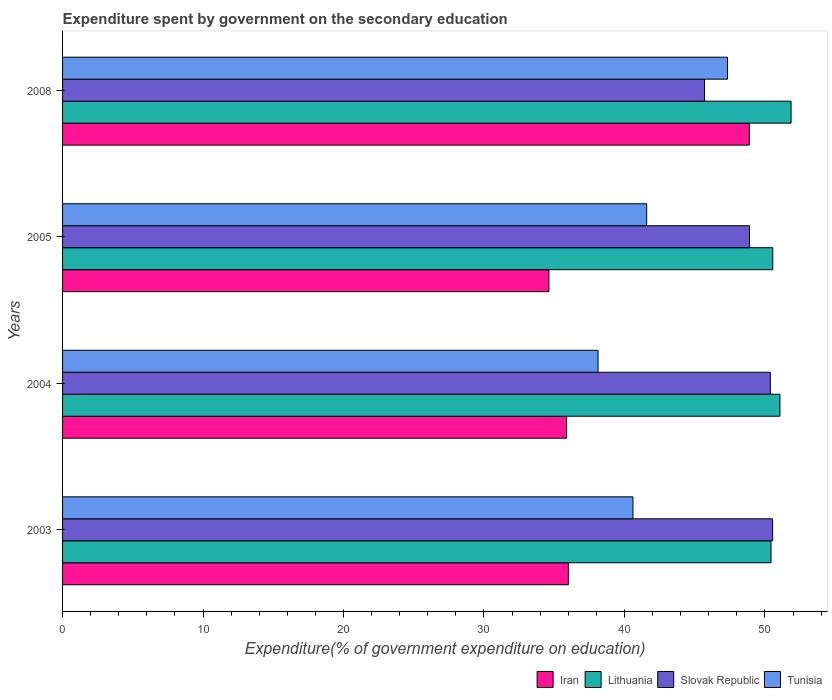How many different coloured bars are there?
Make the answer very short. 4. How many groups of bars are there?
Ensure brevity in your answer.  4. Are the number of bars per tick equal to the number of legend labels?
Ensure brevity in your answer.  Yes. Are the number of bars on each tick of the Y-axis equal?
Provide a short and direct response. Yes. How many bars are there on the 3rd tick from the top?
Offer a very short reply. 4. In how many cases, is the number of bars for a given year not equal to the number of legend labels?
Give a very brief answer. 0. What is the expenditure spent by government on the secondary education in Tunisia in 2003?
Make the answer very short. 40.61. Across all years, what is the maximum expenditure spent by government on the secondary education in Iran?
Give a very brief answer. 48.89. Across all years, what is the minimum expenditure spent by government on the secondary education in Tunisia?
Ensure brevity in your answer.  38.12. What is the total expenditure spent by government on the secondary education in Slovak Republic in the graph?
Your response must be concise. 195.54. What is the difference between the expenditure spent by government on the secondary education in Lithuania in 2003 and that in 2005?
Ensure brevity in your answer.  -0.13. What is the difference between the expenditure spent by government on the secondary education in Iran in 2004 and the expenditure spent by government on the secondary education in Slovak Republic in 2008?
Keep it short and to the point. -9.82. What is the average expenditure spent by government on the secondary education in Tunisia per year?
Offer a very short reply. 41.91. In the year 2003, what is the difference between the expenditure spent by government on the secondary education in Lithuania and expenditure spent by government on the secondary education in Tunisia?
Offer a very short reply. 9.83. In how many years, is the expenditure spent by government on the secondary education in Lithuania greater than 28 %?
Offer a very short reply. 4. What is the ratio of the expenditure spent by government on the secondary education in Slovak Republic in 2003 to that in 2008?
Give a very brief answer. 1.11. What is the difference between the highest and the second highest expenditure spent by government on the secondary education in Tunisia?
Your answer should be very brief. 5.76. What is the difference between the highest and the lowest expenditure spent by government on the secondary education in Iran?
Keep it short and to the point. 14.26. In how many years, is the expenditure spent by government on the secondary education in Slovak Republic greater than the average expenditure spent by government on the secondary education in Slovak Republic taken over all years?
Provide a succinct answer. 3. What does the 1st bar from the top in 2004 represents?
Your response must be concise. Tunisia. What does the 1st bar from the bottom in 2003 represents?
Your response must be concise. Iran. Is it the case that in every year, the sum of the expenditure spent by government on the secondary education in Tunisia and expenditure spent by government on the secondary education in Lithuania is greater than the expenditure spent by government on the secondary education in Iran?
Give a very brief answer. Yes. How many bars are there?
Provide a succinct answer. 16. What is the difference between two consecutive major ticks on the X-axis?
Keep it short and to the point. 10. Are the values on the major ticks of X-axis written in scientific E-notation?
Ensure brevity in your answer.  No. Does the graph contain any zero values?
Your answer should be very brief. No. How many legend labels are there?
Provide a short and direct response. 4. What is the title of the graph?
Your answer should be very brief. Expenditure spent by government on the secondary education. Does "Cuba" appear as one of the legend labels in the graph?
Your answer should be very brief. No. What is the label or title of the X-axis?
Your response must be concise. Expenditure(% of government expenditure on education). What is the label or title of the Y-axis?
Ensure brevity in your answer.  Years. What is the Expenditure(% of government expenditure on education) of Iran in 2003?
Your answer should be compact. 36.01. What is the Expenditure(% of government expenditure on education) of Lithuania in 2003?
Your response must be concise. 50.43. What is the Expenditure(% of government expenditure on education) in Slovak Republic in 2003?
Ensure brevity in your answer.  50.55. What is the Expenditure(% of government expenditure on education) of Tunisia in 2003?
Keep it short and to the point. 40.61. What is the Expenditure(% of government expenditure on education) in Iran in 2004?
Provide a short and direct response. 35.88. What is the Expenditure(% of government expenditure on education) of Lithuania in 2004?
Offer a terse response. 51.07. What is the Expenditure(% of government expenditure on education) of Slovak Republic in 2004?
Provide a short and direct response. 50.39. What is the Expenditure(% of government expenditure on education) in Tunisia in 2004?
Ensure brevity in your answer.  38.12. What is the Expenditure(% of government expenditure on education) in Iran in 2005?
Your answer should be compact. 34.62. What is the Expenditure(% of government expenditure on education) in Lithuania in 2005?
Offer a terse response. 50.56. What is the Expenditure(% of government expenditure on education) in Slovak Republic in 2005?
Your answer should be compact. 48.9. What is the Expenditure(% of government expenditure on education) of Tunisia in 2005?
Provide a succinct answer. 41.58. What is the Expenditure(% of government expenditure on education) in Iran in 2008?
Keep it short and to the point. 48.89. What is the Expenditure(% of government expenditure on education) in Lithuania in 2008?
Provide a short and direct response. 51.86. What is the Expenditure(% of government expenditure on education) in Slovak Republic in 2008?
Your response must be concise. 45.7. What is the Expenditure(% of government expenditure on education) of Tunisia in 2008?
Offer a very short reply. 47.34. Across all years, what is the maximum Expenditure(% of government expenditure on education) in Iran?
Make the answer very short. 48.89. Across all years, what is the maximum Expenditure(% of government expenditure on education) in Lithuania?
Your answer should be very brief. 51.86. Across all years, what is the maximum Expenditure(% of government expenditure on education) in Slovak Republic?
Your response must be concise. 50.55. Across all years, what is the maximum Expenditure(% of government expenditure on education) in Tunisia?
Keep it short and to the point. 47.34. Across all years, what is the minimum Expenditure(% of government expenditure on education) of Iran?
Offer a terse response. 34.62. Across all years, what is the minimum Expenditure(% of government expenditure on education) in Lithuania?
Provide a short and direct response. 50.43. Across all years, what is the minimum Expenditure(% of government expenditure on education) of Slovak Republic?
Make the answer very short. 45.7. Across all years, what is the minimum Expenditure(% of government expenditure on education) in Tunisia?
Your answer should be compact. 38.12. What is the total Expenditure(% of government expenditure on education) of Iran in the graph?
Ensure brevity in your answer.  155.4. What is the total Expenditure(% of government expenditure on education) of Lithuania in the graph?
Give a very brief answer. 203.93. What is the total Expenditure(% of government expenditure on education) in Slovak Republic in the graph?
Make the answer very short. 195.54. What is the total Expenditure(% of government expenditure on education) in Tunisia in the graph?
Ensure brevity in your answer.  167.65. What is the difference between the Expenditure(% of government expenditure on education) in Iran in 2003 and that in 2004?
Your answer should be very brief. 0.13. What is the difference between the Expenditure(% of government expenditure on education) of Lithuania in 2003 and that in 2004?
Ensure brevity in your answer.  -0.64. What is the difference between the Expenditure(% of government expenditure on education) of Slovak Republic in 2003 and that in 2004?
Ensure brevity in your answer.  0.17. What is the difference between the Expenditure(% of government expenditure on education) in Tunisia in 2003 and that in 2004?
Provide a succinct answer. 2.49. What is the difference between the Expenditure(% of government expenditure on education) in Iran in 2003 and that in 2005?
Make the answer very short. 1.38. What is the difference between the Expenditure(% of government expenditure on education) in Lithuania in 2003 and that in 2005?
Offer a terse response. -0.13. What is the difference between the Expenditure(% of government expenditure on education) of Slovak Republic in 2003 and that in 2005?
Make the answer very short. 1.65. What is the difference between the Expenditure(% of government expenditure on education) of Tunisia in 2003 and that in 2005?
Your answer should be compact. -0.98. What is the difference between the Expenditure(% of government expenditure on education) of Iran in 2003 and that in 2008?
Keep it short and to the point. -12.88. What is the difference between the Expenditure(% of government expenditure on education) in Lithuania in 2003 and that in 2008?
Offer a terse response. -1.43. What is the difference between the Expenditure(% of government expenditure on education) of Slovak Republic in 2003 and that in 2008?
Your answer should be very brief. 4.85. What is the difference between the Expenditure(% of government expenditure on education) in Tunisia in 2003 and that in 2008?
Your response must be concise. -6.73. What is the difference between the Expenditure(% of government expenditure on education) of Iran in 2004 and that in 2005?
Offer a very short reply. 1.26. What is the difference between the Expenditure(% of government expenditure on education) of Lithuania in 2004 and that in 2005?
Offer a very short reply. 0.51. What is the difference between the Expenditure(% of government expenditure on education) in Slovak Republic in 2004 and that in 2005?
Your answer should be very brief. 1.49. What is the difference between the Expenditure(% of government expenditure on education) in Tunisia in 2004 and that in 2005?
Provide a short and direct response. -3.46. What is the difference between the Expenditure(% of government expenditure on education) of Iran in 2004 and that in 2008?
Ensure brevity in your answer.  -13.01. What is the difference between the Expenditure(% of government expenditure on education) in Lithuania in 2004 and that in 2008?
Provide a succinct answer. -0.79. What is the difference between the Expenditure(% of government expenditure on education) of Slovak Republic in 2004 and that in 2008?
Your answer should be very brief. 4.68. What is the difference between the Expenditure(% of government expenditure on education) in Tunisia in 2004 and that in 2008?
Your answer should be very brief. -9.22. What is the difference between the Expenditure(% of government expenditure on education) of Iran in 2005 and that in 2008?
Your answer should be compact. -14.26. What is the difference between the Expenditure(% of government expenditure on education) of Lithuania in 2005 and that in 2008?
Keep it short and to the point. -1.3. What is the difference between the Expenditure(% of government expenditure on education) of Slovak Republic in 2005 and that in 2008?
Offer a very short reply. 3.2. What is the difference between the Expenditure(% of government expenditure on education) in Tunisia in 2005 and that in 2008?
Ensure brevity in your answer.  -5.76. What is the difference between the Expenditure(% of government expenditure on education) in Iran in 2003 and the Expenditure(% of government expenditure on education) in Lithuania in 2004?
Your answer should be compact. -15.06. What is the difference between the Expenditure(% of government expenditure on education) in Iran in 2003 and the Expenditure(% of government expenditure on education) in Slovak Republic in 2004?
Provide a short and direct response. -14.38. What is the difference between the Expenditure(% of government expenditure on education) in Iran in 2003 and the Expenditure(% of government expenditure on education) in Tunisia in 2004?
Provide a succinct answer. -2.11. What is the difference between the Expenditure(% of government expenditure on education) in Lithuania in 2003 and the Expenditure(% of government expenditure on education) in Slovak Republic in 2004?
Your answer should be compact. 0.05. What is the difference between the Expenditure(% of government expenditure on education) in Lithuania in 2003 and the Expenditure(% of government expenditure on education) in Tunisia in 2004?
Offer a very short reply. 12.31. What is the difference between the Expenditure(% of government expenditure on education) in Slovak Republic in 2003 and the Expenditure(% of government expenditure on education) in Tunisia in 2004?
Your answer should be very brief. 12.43. What is the difference between the Expenditure(% of government expenditure on education) in Iran in 2003 and the Expenditure(% of government expenditure on education) in Lithuania in 2005?
Your answer should be very brief. -14.55. What is the difference between the Expenditure(% of government expenditure on education) in Iran in 2003 and the Expenditure(% of government expenditure on education) in Slovak Republic in 2005?
Offer a terse response. -12.89. What is the difference between the Expenditure(% of government expenditure on education) in Iran in 2003 and the Expenditure(% of government expenditure on education) in Tunisia in 2005?
Give a very brief answer. -5.58. What is the difference between the Expenditure(% of government expenditure on education) of Lithuania in 2003 and the Expenditure(% of government expenditure on education) of Slovak Republic in 2005?
Your response must be concise. 1.53. What is the difference between the Expenditure(% of government expenditure on education) of Lithuania in 2003 and the Expenditure(% of government expenditure on education) of Tunisia in 2005?
Offer a terse response. 8.85. What is the difference between the Expenditure(% of government expenditure on education) of Slovak Republic in 2003 and the Expenditure(% of government expenditure on education) of Tunisia in 2005?
Give a very brief answer. 8.97. What is the difference between the Expenditure(% of government expenditure on education) in Iran in 2003 and the Expenditure(% of government expenditure on education) in Lithuania in 2008?
Your answer should be very brief. -15.86. What is the difference between the Expenditure(% of government expenditure on education) of Iran in 2003 and the Expenditure(% of government expenditure on education) of Slovak Republic in 2008?
Give a very brief answer. -9.69. What is the difference between the Expenditure(% of government expenditure on education) in Iran in 2003 and the Expenditure(% of government expenditure on education) in Tunisia in 2008?
Provide a succinct answer. -11.33. What is the difference between the Expenditure(% of government expenditure on education) in Lithuania in 2003 and the Expenditure(% of government expenditure on education) in Slovak Republic in 2008?
Your answer should be compact. 4.73. What is the difference between the Expenditure(% of government expenditure on education) in Lithuania in 2003 and the Expenditure(% of government expenditure on education) in Tunisia in 2008?
Offer a very short reply. 3.09. What is the difference between the Expenditure(% of government expenditure on education) in Slovak Republic in 2003 and the Expenditure(% of government expenditure on education) in Tunisia in 2008?
Ensure brevity in your answer.  3.21. What is the difference between the Expenditure(% of government expenditure on education) in Iran in 2004 and the Expenditure(% of government expenditure on education) in Lithuania in 2005?
Offer a terse response. -14.68. What is the difference between the Expenditure(% of government expenditure on education) in Iran in 2004 and the Expenditure(% of government expenditure on education) in Slovak Republic in 2005?
Provide a short and direct response. -13.02. What is the difference between the Expenditure(% of government expenditure on education) of Iran in 2004 and the Expenditure(% of government expenditure on education) of Tunisia in 2005?
Give a very brief answer. -5.7. What is the difference between the Expenditure(% of government expenditure on education) in Lithuania in 2004 and the Expenditure(% of government expenditure on education) in Slovak Republic in 2005?
Provide a short and direct response. 2.17. What is the difference between the Expenditure(% of government expenditure on education) of Lithuania in 2004 and the Expenditure(% of government expenditure on education) of Tunisia in 2005?
Keep it short and to the point. 9.49. What is the difference between the Expenditure(% of government expenditure on education) in Slovak Republic in 2004 and the Expenditure(% of government expenditure on education) in Tunisia in 2005?
Offer a terse response. 8.8. What is the difference between the Expenditure(% of government expenditure on education) of Iran in 2004 and the Expenditure(% of government expenditure on education) of Lithuania in 2008?
Your answer should be compact. -15.98. What is the difference between the Expenditure(% of government expenditure on education) in Iran in 2004 and the Expenditure(% of government expenditure on education) in Slovak Republic in 2008?
Your answer should be very brief. -9.82. What is the difference between the Expenditure(% of government expenditure on education) in Iran in 2004 and the Expenditure(% of government expenditure on education) in Tunisia in 2008?
Offer a very short reply. -11.46. What is the difference between the Expenditure(% of government expenditure on education) in Lithuania in 2004 and the Expenditure(% of government expenditure on education) in Slovak Republic in 2008?
Offer a very short reply. 5.37. What is the difference between the Expenditure(% of government expenditure on education) in Lithuania in 2004 and the Expenditure(% of government expenditure on education) in Tunisia in 2008?
Make the answer very short. 3.73. What is the difference between the Expenditure(% of government expenditure on education) of Slovak Republic in 2004 and the Expenditure(% of government expenditure on education) of Tunisia in 2008?
Keep it short and to the point. 3.04. What is the difference between the Expenditure(% of government expenditure on education) in Iran in 2005 and the Expenditure(% of government expenditure on education) in Lithuania in 2008?
Give a very brief answer. -17.24. What is the difference between the Expenditure(% of government expenditure on education) of Iran in 2005 and the Expenditure(% of government expenditure on education) of Slovak Republic in 2008?
Your answer should be very brief. -11.08. What is the difference between the Expenditure(% of government expenditure on education) of Iran in 2005 and the Expenditure(% of government expenditure on education) of Tunisia in 2008?
Provide a succinct answer. -12.72. What is the difference between the Expenditure(% of government expenditure on education) in Lithuania in 2005 and the Expenditure(% of government expenditure on education) in Slovak Republic in 2008?
Give a very brief answer. 4.86. What is the difference between the Expenditure(% of government expenditure on education) in Lithuania in 2005 and the Expenditure(% of government expenditure on education) in Tunisia in 2008?
Keep it short and to the point. 3.22. What is the difference between the Expenditure(% of government expenditure on education) of Slovak Republic in 2005 and the Expenditure(% of government expenditure on education) of Tunisia in 2008?
Make the answer very short. 1.56. What is the average Expenditure(% of government expenditure on education) in Iran per year?
Offer a terse response. 38.85. What is the average Expenditure(% of government expenditure on education) in Lithuania per year?
Your answer should be compact. 50.98. What is the average Expenditure(% of government expenditure on education) of Slovak Republic per year?
Your answer should be compact. 48.88. What is the average Expenditure(% of government expenditure on education) in Tunisia per year?
Your response must be concise. 41.91. In the year 2003, what is the difference between the Expenditure(% of government expenditure on education) in Iran and Expenditure(% of government expenditure on education) in Lithuania?
Your answer should be very brief. -14.43. In the year 2003, what is the difference between the Expenditure(% of government expenditure on education) of Iran and Expenditure(% of government expenditure on education) of Slovak Republic?
Ensure brevity in your answer.  -14.54. In the year 2003, what is the difference between the Expenditure(% of government expenditure on education) of Iran and Expenditure(% of government expenditure on education) of Tunisia?
Your response must be concise. -4.6. In the year 2003, what is the difference between the Expenditure(% of government expenditure on education) of Lithuania and Expenditure(% of government expenditure on education) of Slovak Republic?
Ensure brevity in your answer.  -0.12. In the year 2003, what is the difference between the Expenditure(% of government expenditure on education) in Lithuania and Expenditure(% of government expenditure on education) in Tunisia?
Keep it short and to the point. 9.83. In the year 2003, what is the difference between the Expenditure(% of government expenditure on education) of Slovak Republic and Expenditure(% of government expenditure on education) of Tunisia?
Give a very brief answer. 9.95. In the year 2004, what is the difference between the Expenditure(% of government expenditure on education) in Iran and Expenditure(% of government expenditure on education) in Lithuania?
Ensure brevity in your answer.  -15.19. In the year 2004, what is the difference between the Expenditure(% of government expenditure on education) of Iran and Expenditure(% of government expenditure on education) of Slovak Republic?
Offer a very short reply. -14.5. In the year 2004, what is the difference between the Expenditure(% of government expenditure on education) of Iran and Expenditure(% of government expenditure on education) of Tunisia?
Your response must be concise. -2.24. In the year 2004, what is the difference between the Expenditure(% of government expenditure on education) in Lithuania and Expenditure(% of government expenditure on education) in Slovak Republic?
Provide a succinct answer. 0.69. In the year 2004, what is the difference between the Expenditure(% of government expenditure on education) in Lithuania and Expenditure(% of government expenditure on education) in Tunisia?
Give a very brief answer. 12.95. In the year 2004, what is the difference between the Expenditure(% of government expenditure on education) of Slovak Republic and Expenditure(% of government expenditure on education) of Tunisia?
Provide a succinct answer. 12.26. In the year 2005, what is the difference between the Expenditure(% of government expenditure on education) in Iran and Expenditure(% of government expenditure on education) in Lithuania?
Keep it short and to the point. -15.94. In the year 2005, what is the difference between the Expenditure(% of government expenditure on education) in Iran and Expenditure(% of government expenditure on education) in Slovak Republic?
Your answer should be very brief. -14.28. In the year 2005, what is the difference between the Expenditure(% of government expenditure on education) in Iran and Expenditure(% of government expenditure on education) in Tunisia?
Keep it short and to the point. -6.96. In the year 2005, what is the difference between the Expenditure(% of government expenditure on education) in Lithuania and Expenditure(% of government expenditure on education) in Slovak Republic?
Offer a terse response. 1.66. In the year 2005, what is the difference between the Expenditure(% of government expenditure on education) of Lithuania and Expenditure(% of government expenditure on education) of Tunisia?
Your answer should be very brief. 8.98. In the year 2005, what is the difference between the Expenditure(% of government expenditure on education) of Slovak Republic and Expenditure(% of government expenditure on education) of Tunisia?
Your response must be concise. 7.32. In the year 2008, what is the difference between the Expenditure(% of government expenditure on education) in Iran and Expenditure(% of government expenditure on education) in Lithuania?
Provide a short and direct response. -2.98. In the year 2008, what is the difference between the Expenditure(% of government expenditure on education) in Iran and Expenditure(% of government expenditure on education) in Slovak Republic?
Offer a terse response. 3.19. In the year 2008, what is the difference between the Expenditure(% of government expenditure on education) of Iran and Expenditure(% of government expenditure on education) of Tunisia?
Give a very brief answer. 1.55. In the year 2008, what is the difference between the Expenditure(% of government expenditure on education) of Lithuania and Expenditure(% of government expenditure on education) of Slovak Republic?
Provide a short and direct response. 6.16. In the year 2008, what is the difference between the Expenditure(% of government expenditure on education) of Lithuania and Expenditure(% of government expenditure on education) of Tunisia?
Provide a succinct answer. 4.52. In the year 2008, what is the difference between the Expenditure(% of government expenditure on education) of Slovak Republic and Expenditure(% of government expenditure on education) of Tunisia?
Your answer should be compact. -1.64. What is the ratio of the Expenditure(% of government expenditure on education) of Lithuania in 2003 to that in 2004?
Make the answer very short. 0.99. What is the ratio of the Expenditure(% of government expenditure on education) of Tunisia in 2003 to that in 2004?
Make the answer very short. 1.07. What is the ratio of the Expenditure(% of government expenditure on education) in Iran in 2003 to that in 2005?
Offer a terse response. 1.04. What is the ratio of the Expenditure(% of government expenditure on education) in Slovak Republic in 2003 to that in 2005?
Offer a terse response. 1.03. What is the ratio of the Expenditure(% of government expenditure on education) of Tunisia in 2003 to that in 2005?
Your answer should be compact. 0.98. What is the ratio of the Expenditure(% of government expenditure on education) in Iran in 2003 to that in 2008?
Your answer should be very brief. 0.74. What is the ratio of the Expenditure(% of government expenditure on education) in Lithuania in 2003 to that in 2008?
Provide a short and direct response. 0.97. What is the ratio of the Expenditure(% of government expenditure on education) of Slovak Republic in 2003 to that in 2008?
Offer a terse response. 1.11. What is the ratio of the Expenditure(% of government expenditure on education) in Tunisia in 2003 to that in 2008?
Offer a very short reply. 0.86. What is the ratio of the Expenditure(% of government expenditure on education) in Iran in 2004 to that in 2005?
Offer a terse response. 1.04. What is the ratio of the Expenditure(% of government expenditure on education) in Slovak Republic in 2004 to that in 2005?
Ensure brevity in your answer.  1.03. What is the ratio of the Expenditure(% of government expenditure on education) of Tunisia in 2004 to that in 2005?
Your response must be concise. 0.92. What is the ratio of the Expenditure(% of government expenditure on education) of Iran in 2004 to that in 2008?
Provide a short and direct response. 0.73. What is the ratio of the Expenditure(% of government expenditure on education) in Lithuania in 2004 to that in 2008?
Your response must be concise. 0.98. What is the ratio of the Expenditure(% of government expenditure on education) in Slovak Republic in 2004 to that in 2008?
Your response must be concise. 1.1. What is the ratio of the Expenditure(% of government expenditure on education) in Tunisia in 2004 to that in 2008?
Your answer should be compact. 0.81. What is the ratio of the Expenditure(% of government expenditure on education) in Iran in 2005 to that in 2008?
Offer a very short reply. 0.71. What is the ratio of the Expenditure(% of government expenditure on education) in Lithuania in 2005 to that in 2008?
Give a very brief answer. 0.97. What is the ratio of the Expenditure(% of government expenditure on education) of Slovak Republic in 2005 to that in 2008?
Your answer should be compact. 1.07. What is the ratio of the Expenditure(% of government expenditure on education) in Tunisia in 2005 to that in 2008?
Ensure brevity in your answer.  0.88. What is the difference between the highest and the second highest Expenditure(% of government expenditure on education) in Iran?
Ensure brevity in your answer.  12.88. What is the difference between the highest and the second highest Expenditure(% of government expenditure on education) of Lithuania?
Make the answer very short. 0.79. What is the difference between the highest and the second highest Expenditure(% of government expenditure on education) in Slovak Republic?
Give a very brief answer. 0.17. What is the difference between the highest and the second highest Expenditure(% of government expenditure on education) in Tunisia?
Ensure brevity in your answer.  5.76. What is the difference between the highest and the lowest Expenditure(% of government expenditure on education) of Iran?
Provide a succinct answer. 14.26. What is the difference between the highest and the lowest Expenditure(% of government expenditure on education) of Lithuania?
Ensure brevity in your answer.  1.43. What is the difference between the highest and the lowest Expenditure(% of government expenditure on education) of Slovak Republic?
Offer a very short reply. 4.85. What is the difference between the highest and the lowest Expenditure(% of government expenditure on education) of Tunisia?
Offer a very short reply. 9.22. 